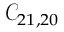<formula> <loc_0><loc_0><loc_500><loc_500>\mathcal { C } _ { 2 1 , 2 0 }</formula> 